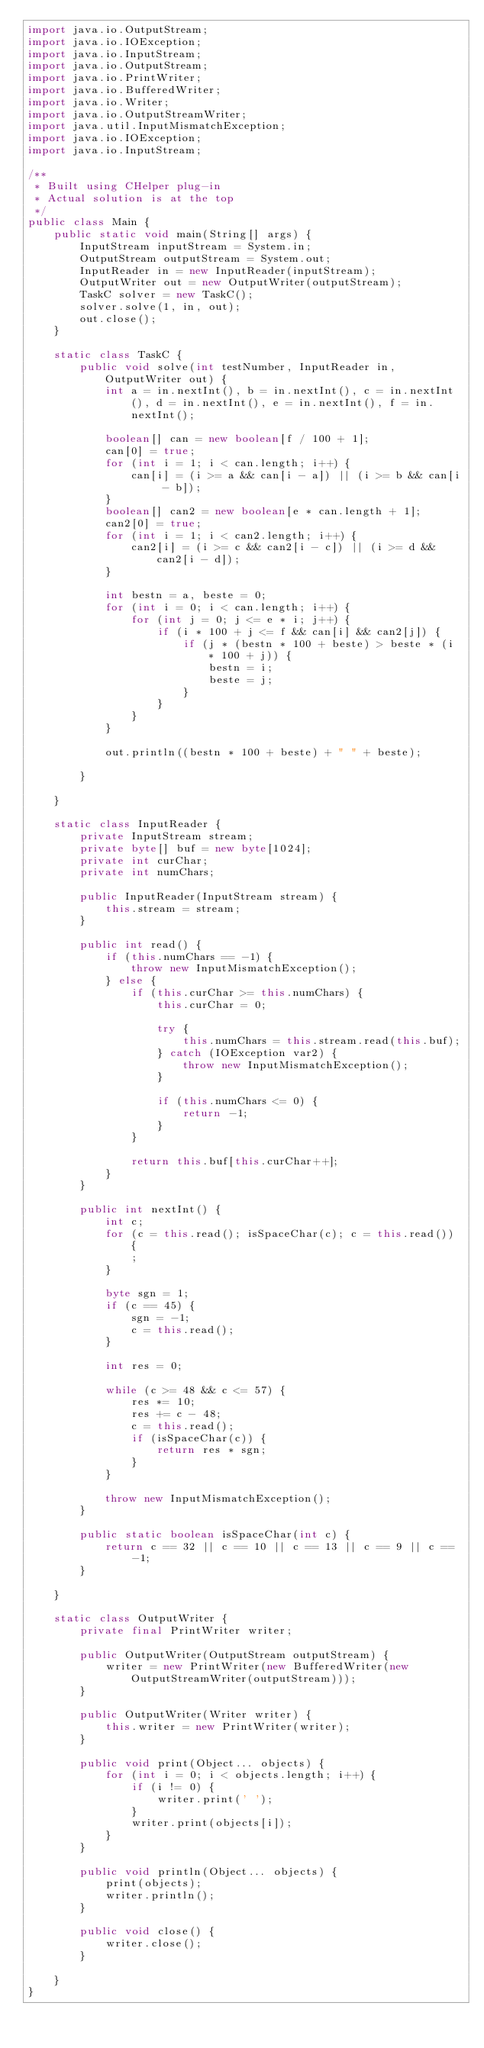<code> <loc_0><loc_0><loc_500><loc_500><_Java_>import java.io.OutputStream;
import java.io.IOException;
import java.io.InputStream;
import java.io.OutputStream;
import java.io.PrintWriter;
import java.io.BufferedWriter;
import java.io.Writer;
import java.io.OutputStreamWriter;
import java.util.InputMismatchException;
import java.io.IOException;
import java.io.InputStream;

/**
 * Built using CHelper plug-in
 * Actual solution is at the top
 */
public class Main {
    public static void main(String[] args) {
        InputStream inputStream = System.in;
        OutputStream outputStream = System.out;
        InputReader in = new InputReader(inputStream);
        OutputWriter out = new OutputWriter(outputStream);
        TaskC solver = new TaskC();
        solver.solve(1, in, out);
        out.close();
    }

    static class TaskC {
        public void solve(int testNumber, InputReader in, OutputWriter out) {
            int a = in.nextInt(), b = in.nextInt(), c = in.nextInt(), d = in.nextInt(), e = in.nextInt(), f = in.nextInt();

            boolean[] can = new boolean[f / 100 + 1];
            can[0] = true;
            for (int i = 1; i < can.length; i++) {
                can[i] = (i >= a && can[i - a]) || (i >= b && can[i - b]);
            }
            boolean[] can2 = new boolean[e * can.length + 1];
            can2[0] = true;
            for (int i = 1; i < can2.length; i++) {
                can2[i] = (i >= c && can2[i - c]) || (i >= d && can2[i - d]);
            }

            int bestn = a, beste = 0;
            for (int i = 0; i < can.length; i++) {
                for (int j = 0; j <= e * i; j++) {
                    if (i * 100 + j <= f && can[i] && can2[j]) {
                        if (j * (bestn * 100 + beste) > beste * (i * 100 + j)) {
                            bestn = i;
                            beste = j;
                        }
                    }
                }
            }

            out.println((bestn * 100 + beste) + " " + beste);

        }

    }

    static class InputReader {
        private InputStream stream;
        private byte[] buf = new byte[1024];
        private int curChar;
        private int numChars;

        public InputReader(InputStream stream) {
            this.stream = stream;
        }

        public int read() {
            if (this.numChars == -1) {
                throw new InputMismatchException();
            } else {
                if (this.curChar >= this.numChars) {
                    this.curChar = 0;

                    try {
                        this.numChars = this.stream.read(this.buf);
                    } catch (IOException var2) {
                        throw new InputMismatchException();
                    }

                    if (this.numChars <= 0) {
                        return -1;
                    }
                }

                return this.buf[this.curChar++];
            }
        }

        public int nextInt() {
            int c;
            for (c = this.read(); isSpaceChar(c); c = this.read()) {
                ;
            }

            byte sgn = 1;
            if (c == 45) {
                sgn = -1;
                c = this.read();
            }

            int res = 0;

            while (c >= 48 && c <= 57) {
                res *= 10;
                res += c - 48;
                c = this.read();
                if (isSpaceChar(c)) {
                    return res * sgn;
                }
            }

            throw new InputMismatchException();
        }

        public static boolean isSpaceChar(int c) {
            return c == 32 || c == 10 || c == 13 || c == 9 || c == -1;
        }

    }

    static class OutputWriter {
        private final PrintWriter writer;

        public OutputWriter(OutputStream outputStream) {
            writer = new PrintWriter(new BufferedWriter(new OutputStreamWriter(outputStream)));
        }

        public OutputWriter(Writer writer) {
            this.writer = new PrintWriter(writer);
        }

        public void print(Object... objects) {
            for (int i = 0; i < objects.length; i++) {
                if (i != 0) {
                    writer.print(' ');
                }
                writer.print(objects[i]);
            }
        }

        public void println(Object... objects) {
            print(objects);
            writer.println();
        }

        public void close() {
            writer.close();
        }

    }
}

</code> 